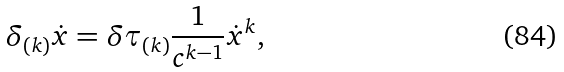<formula> <loc_0><loc_0><loc_500><loc_500>\delta _ { ( k ) } \dot { x } = \delta \tau _ { ( k ) } \frac { 1 } { c ^ { k - 1 } } \dot { x } ^ { k } ,</formula> 